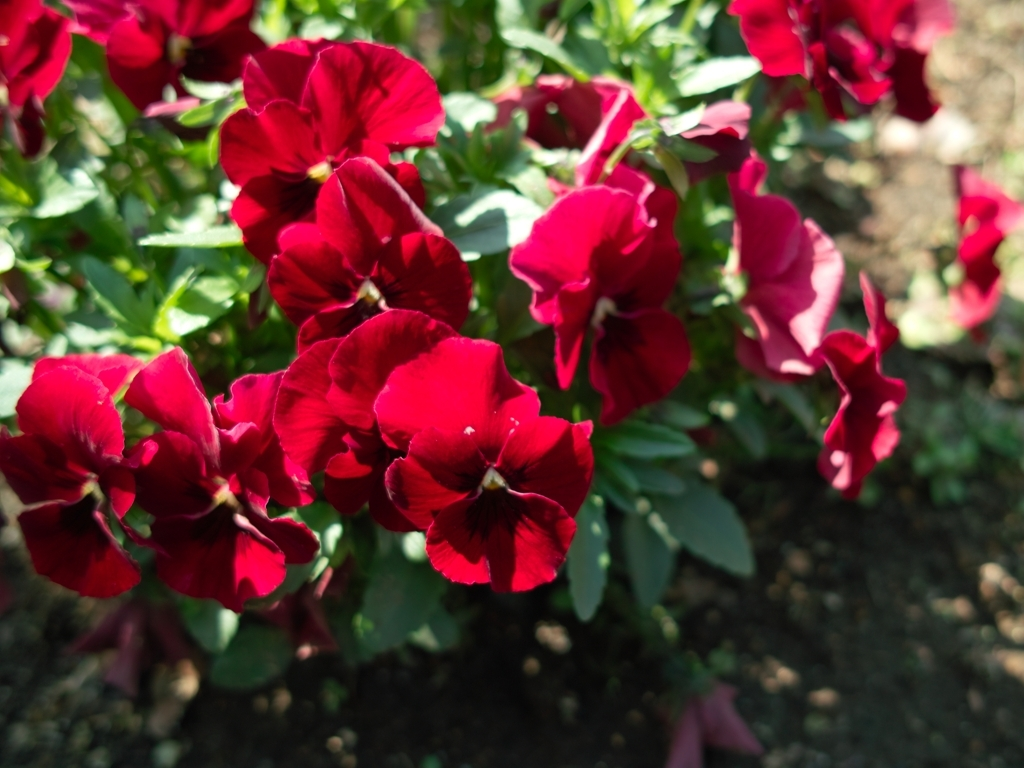Can you tell me about the environmental conditions of the place where this picture was taken? The lighting and the lushness of the plants suggest this photo was taken in a well-lit area with ample sunlight, which is conducive to the growth of flowering plants like the petunias shown. The soil looks well-tended, implying that this could be a cultivated garden environment. What time of day does this photo appear to have been taken? Judging by the bright but diffused quality of light and the lack of harsh shadows, it appears to be taken during the morning or late afternoon, when the sun is lower in the sky. 